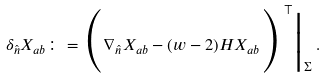<formula> <loc_0><loc_0><loc_500><loc_500>\delta _ { \hat { n } } X _ { a b } \colon = \Big ( \nabla _ { \hat { n } } X _ { a b } - ( w - 2 ) H X _ { a b } \Big ) ^ { \, \top } \Big | _ { \Sigma } \, .</formula> 